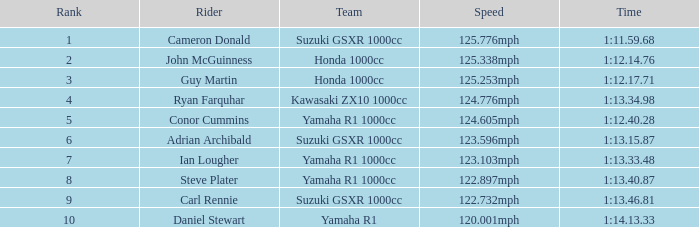What position does the team with a time of 1:12.40.28 hold in the ranking? 5.0. 